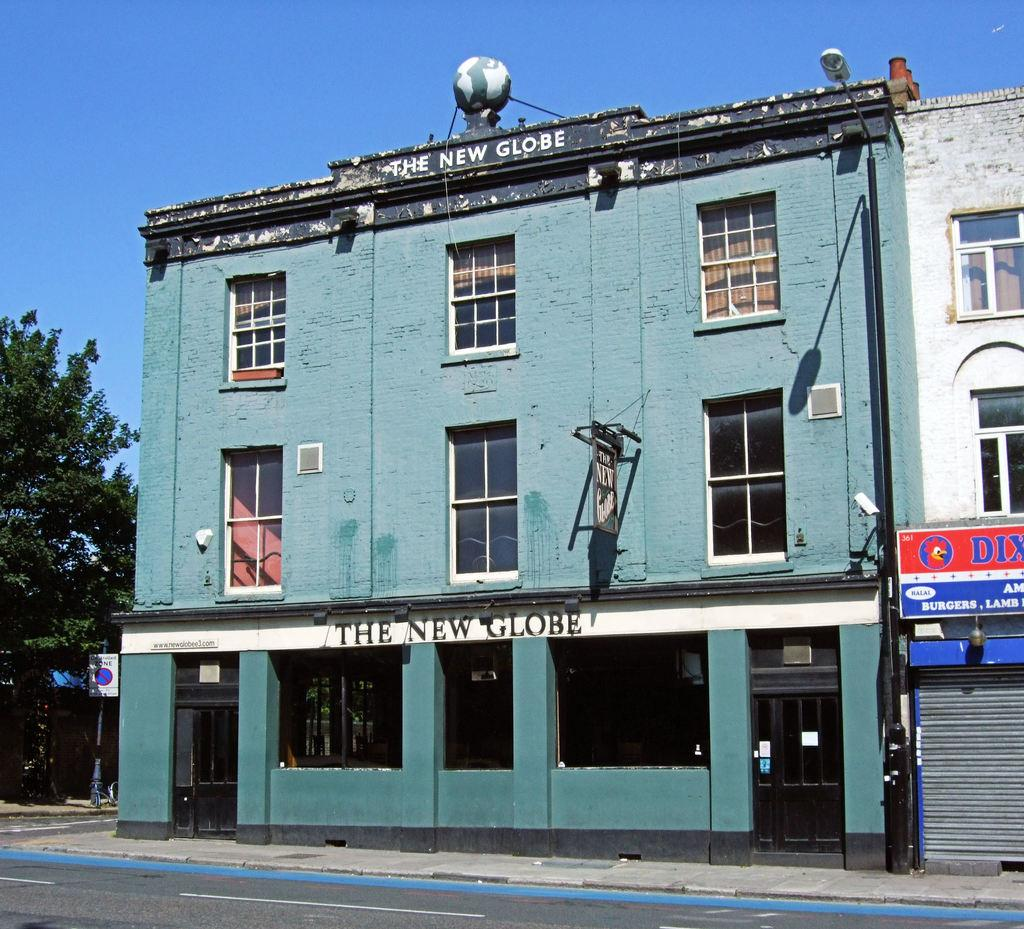What type of structure is in the image? There is a building in the image. What feature can be seen on the building? The building has windows. Is there any text present on the building? Yes, there is text written on the building. What can be seen in the image besides the building? Trees and the sky are visible in the image. How many sheets of paper are being used to construct the bridge in the image? There is no bridge present in the image, and therefore no sheets of paper are being used for construction. 